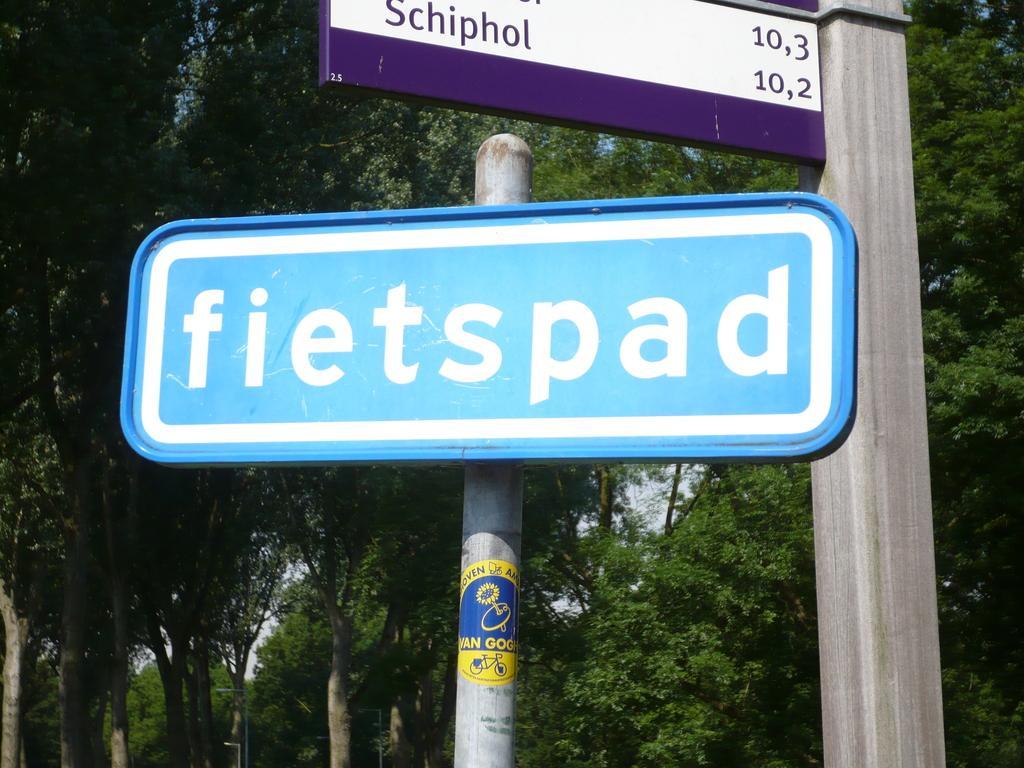How would you summarize this image in a sentence or two? In this image there are boards. In the background there are trees and sky. 